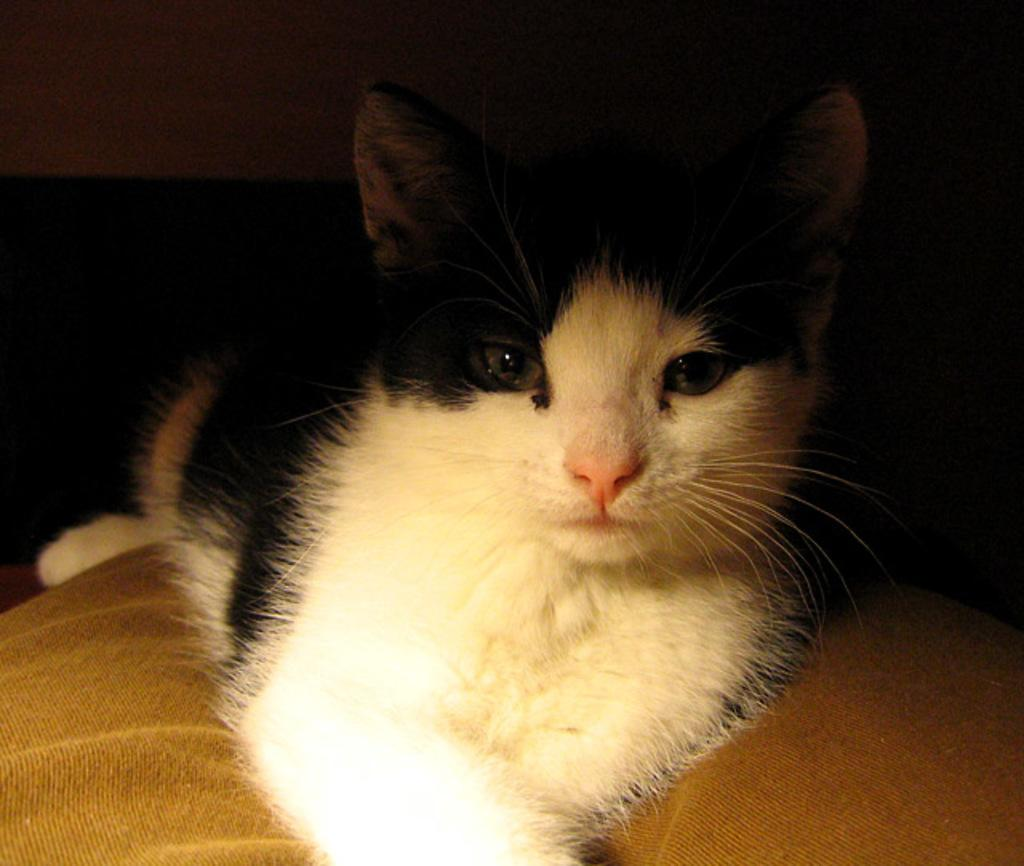What type of animal is in the image? There is a cat in the image. Can you describe the color pattern of the cat? The cat is white and black in color. What is the cat sitting on in the image? The cat is sitting on a brown surface. How would you describe the overall lighting or color of the background in the image? The background of the image is dark. What type of beast is standing on the stem in the image? There is no beast or stem present in the image; it features a cat sitting on a brown surface. 